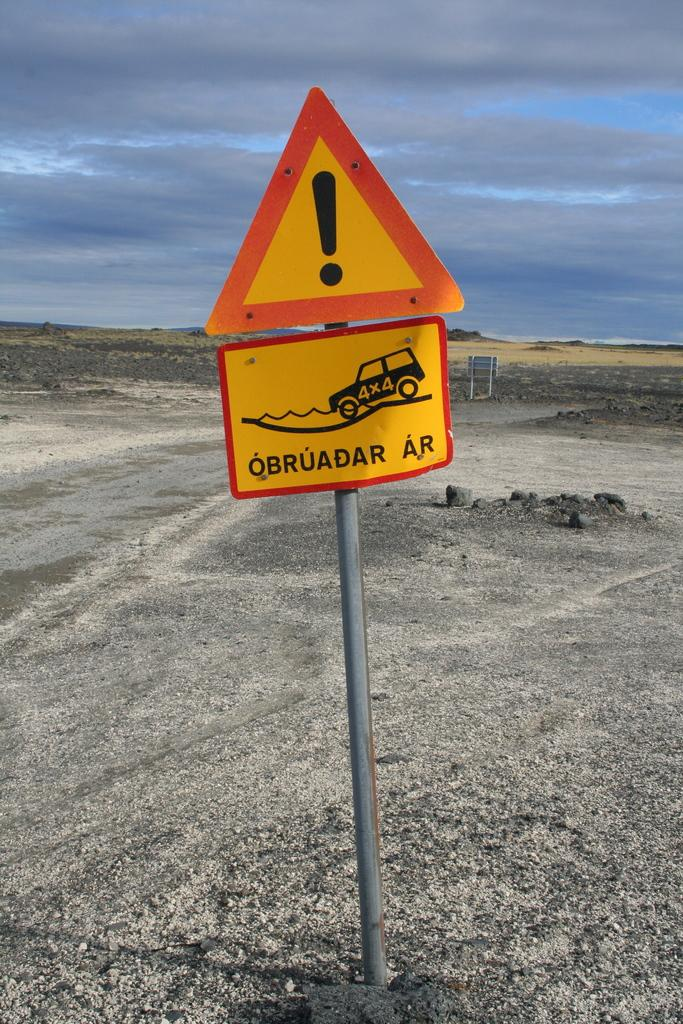<image>
Relay a brief, clear account of the picture shown. a sign that ha an exclamation point on it 